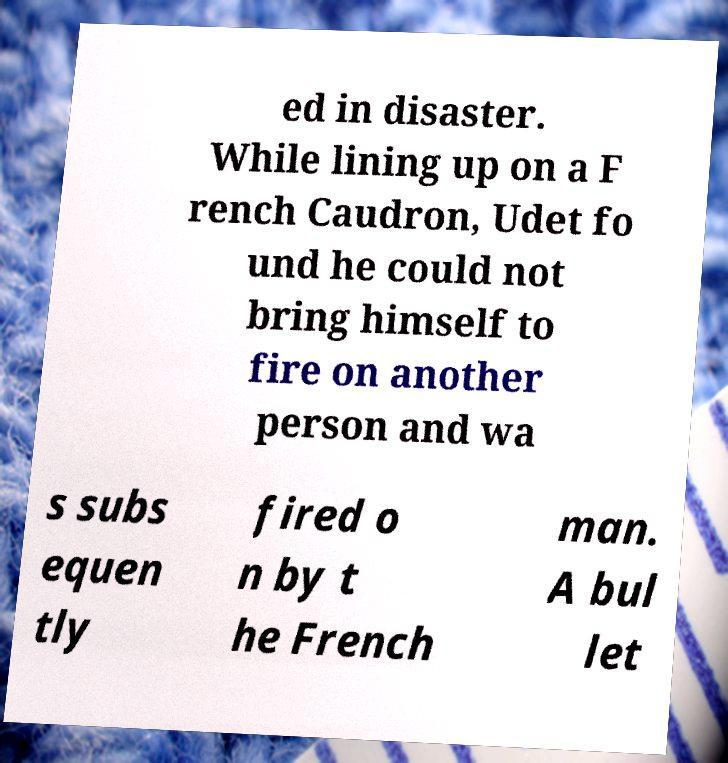Please read and relay the text visible in this image. What does it say? ed in disaster. While lining up on a F rench Caudron, Udet fo und he could not bring himself to fire on another person and wa s subs equen tly fired o n by t he French man. A bul let 